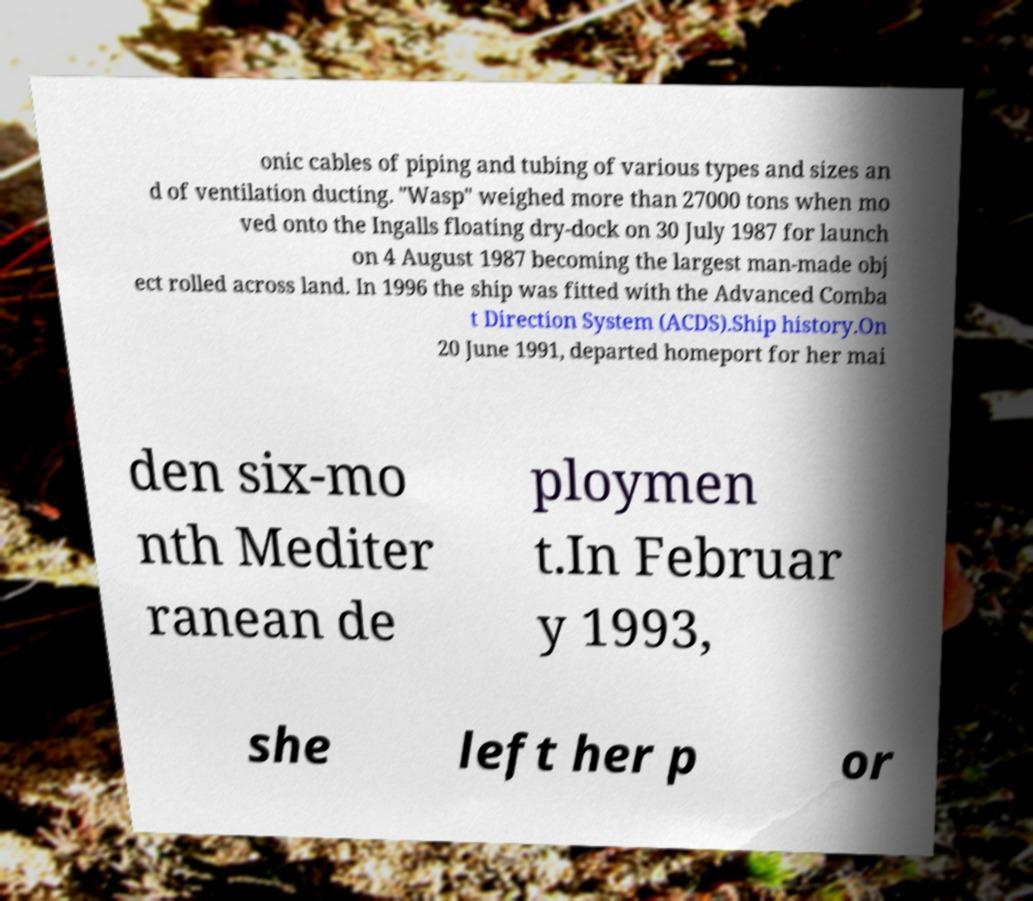Could you assist in decoding the text presented in this image and type it out clearly? onic cables of piping and tubing of various types and sizes an d of ventilation ducting. "Wasp" weighed more than 27000 tons when mo ved onto the Ingalls floating dry-dock on 30 July 1987 for launch on 4 August 1987 becoming the largest man-made obj ect rolled across land. In 1996 the ship was fitted with the Advanced Comba t Direction System (ACDS).Ship history.On 20 June 1991, departed homeport for her mai den six-mo nth Mediter ranean de ploymen t.In Februar y 1993, she left her p or 